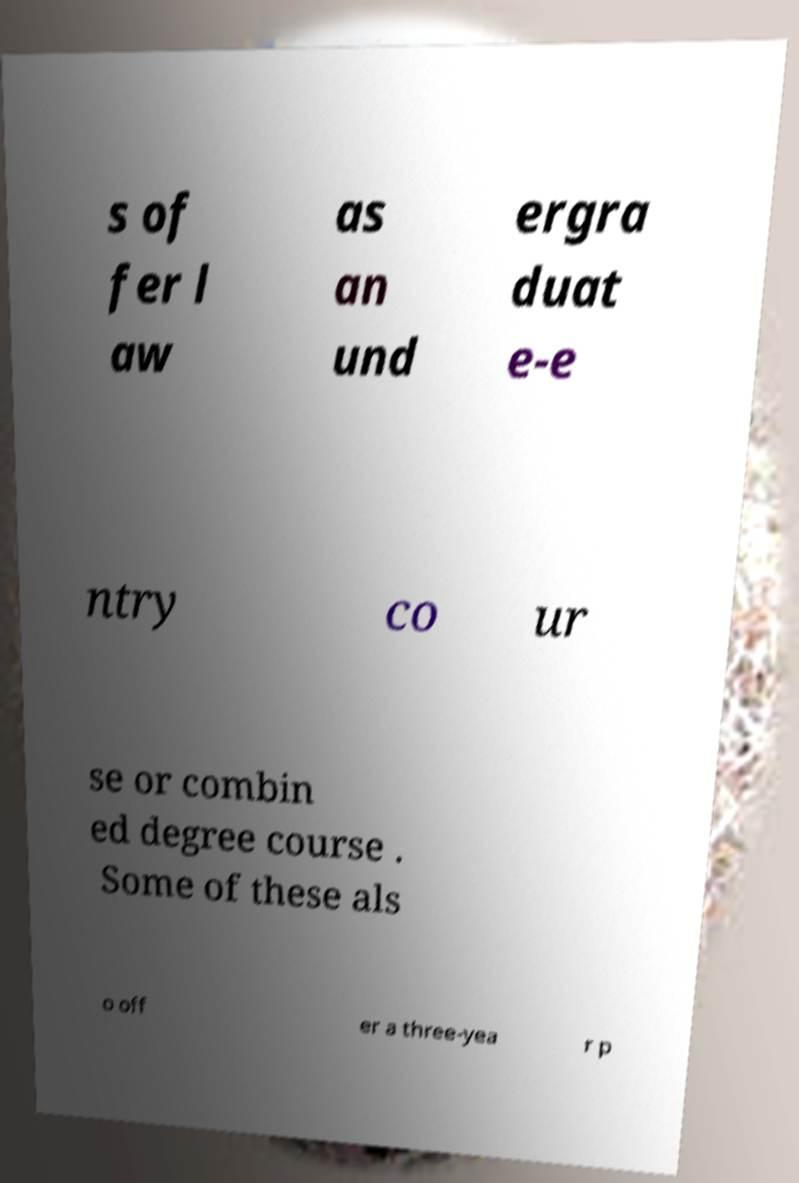What messages or text are displayed in this image? I need them in a readable, typed format. s of fer l aw as an und ergra duat e-e ntry co ur se or combin ed degree course . Some of these als o off er a three-yea r p 